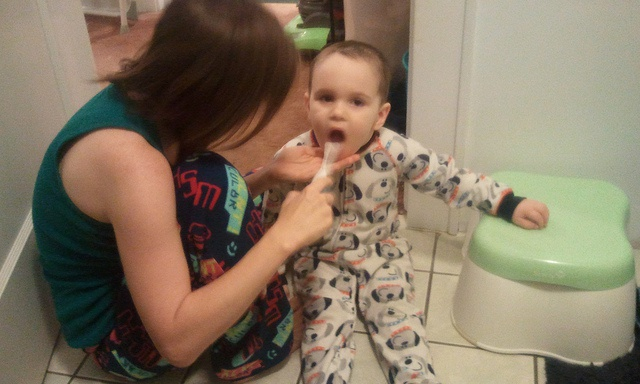Describe the objects in this image and their specific colors. I can see people in gray, black, brown, salmon, and maroon tones, people in gray and tan tones, toilet in gray, tan, lightgreen, and darkgray tones, and toothbrush in gray and tan tones in this image. 